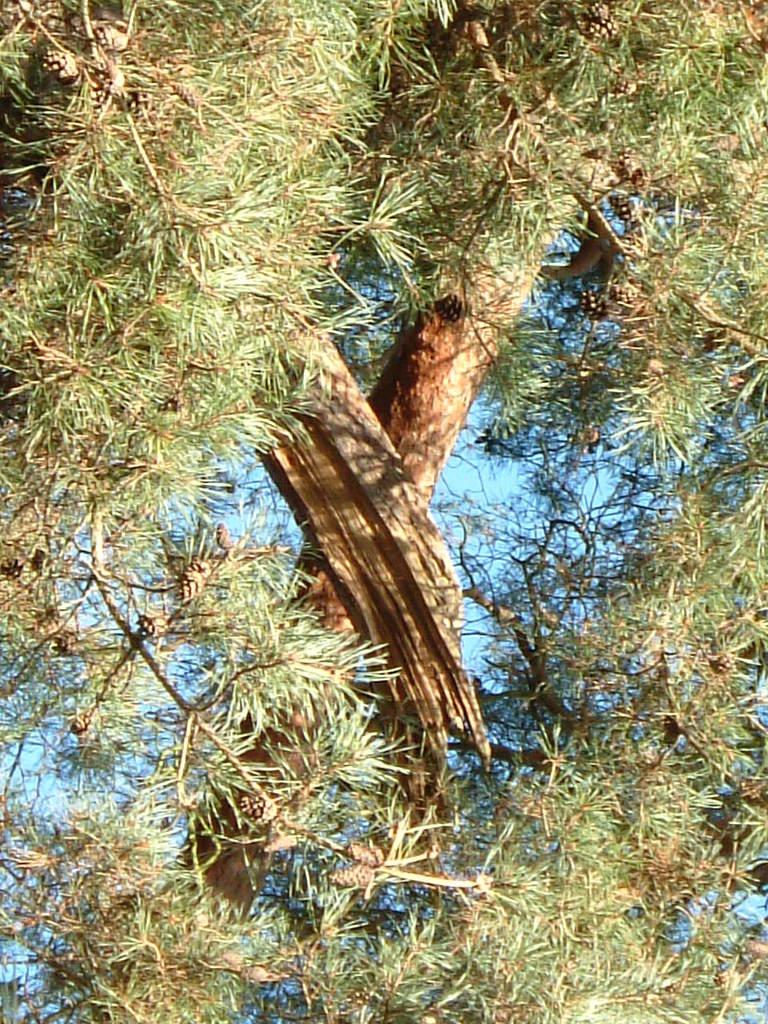What type of tree is present in the image? There is a pine tree with cones in the image. What can be seen in the background of the image? The sky is visible in the background of the image. What type of verse can be heard recited by the pigs in the image? There are no pigs or verses present in the image; it features a pine tree with cones and a visible sky. 